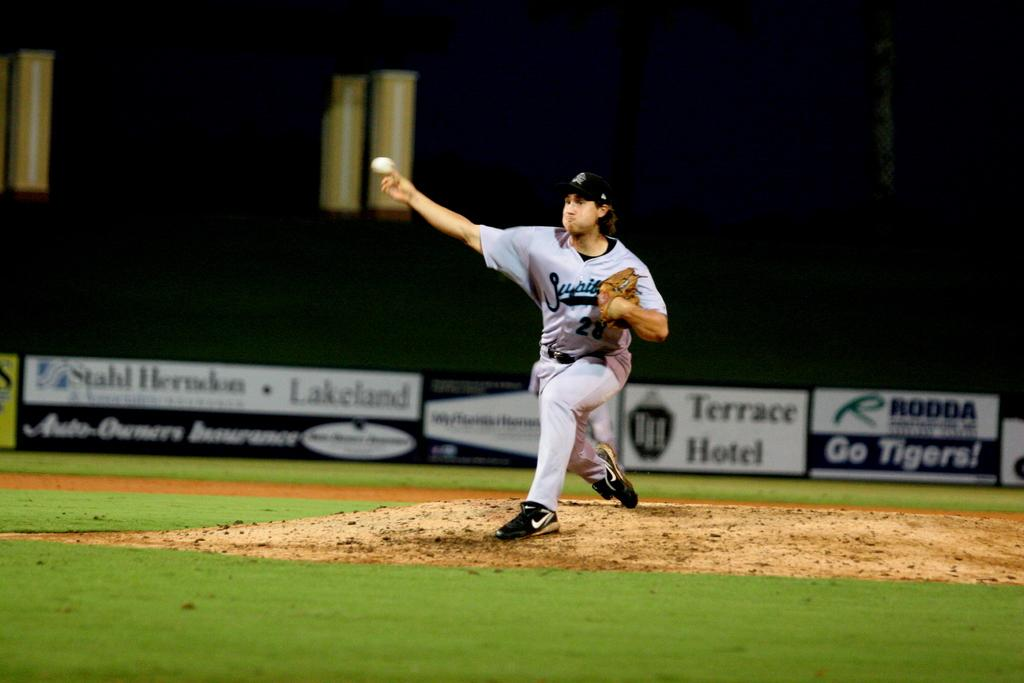<image>
Write a terse but informative summary of the picture. Behind a pitcher appears and advertisement for the Terrace Hotel. 